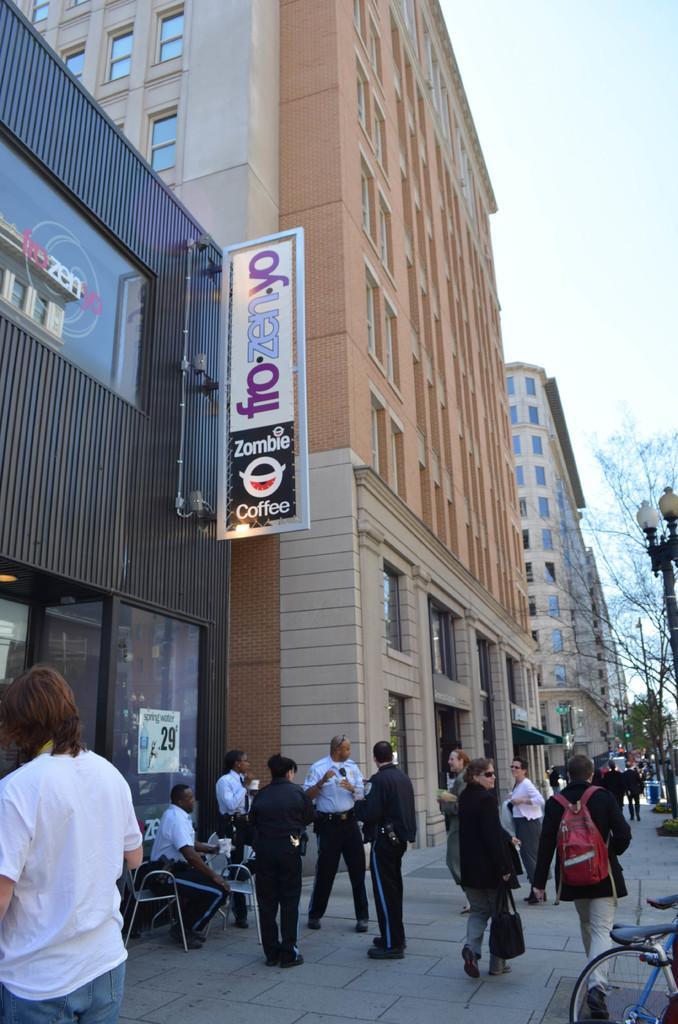How would you summarize this image in a sentence or two? In this image there is a path on which there are few people walking on it. There are buildings on the left side. On the left side there are two officers sitting in the chairs. On the right side bottom there is a cycle. On the left side top there is a coffee store. At the top there is sky. Beside the path there are trees and lights. 